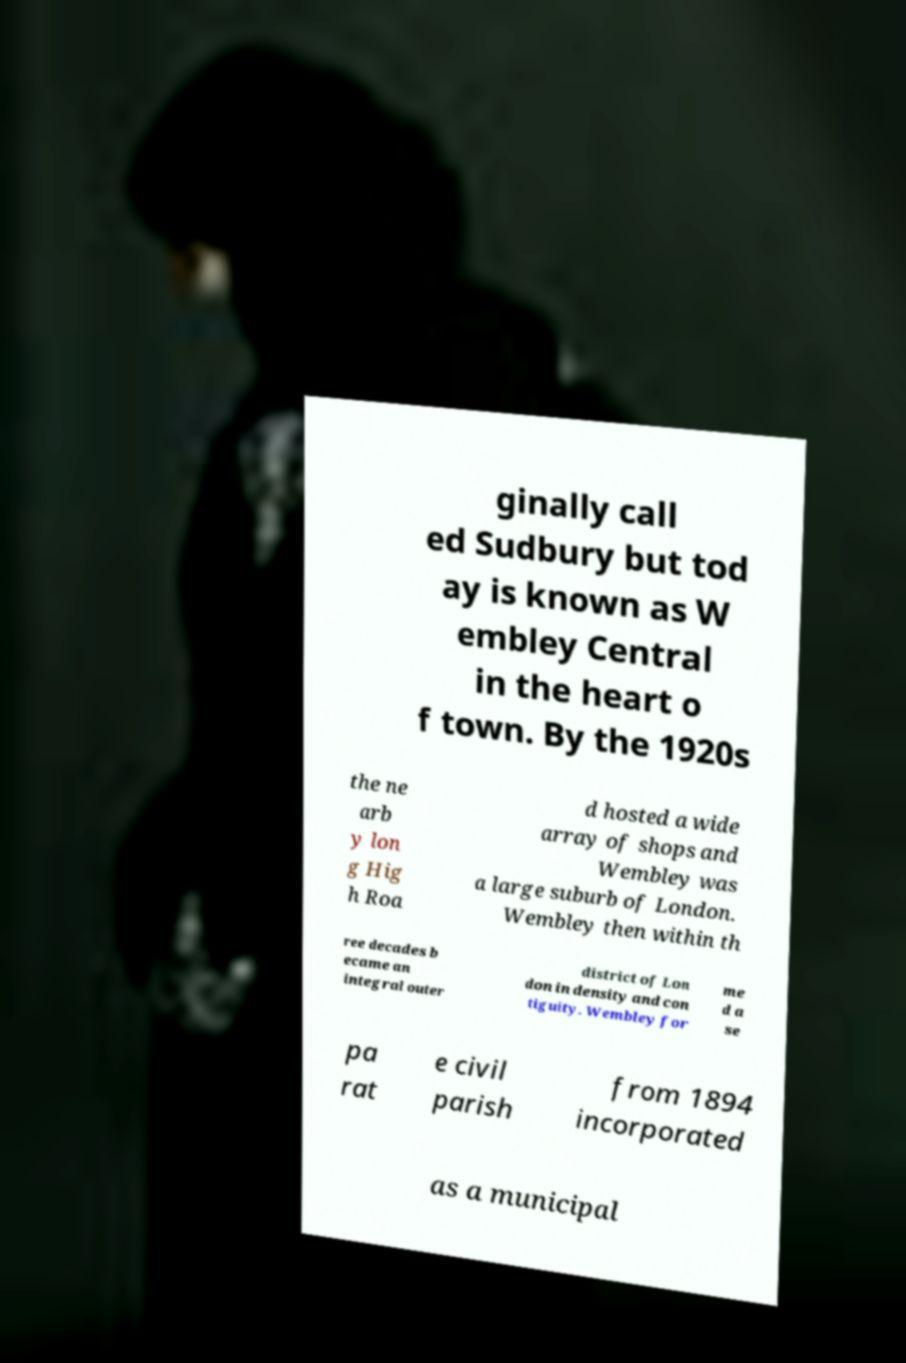Please read and relay the text visible in this image. What does it say? ginally call ed Sudbury but tod ay is known as W embley Central in the heart o f town. By the 1920s the ne arb y lon g Hig h Roa d hosted a wide array of shops and Wembley was a large suburb of London. Wembley then within th ree decades b ecame an integral outer district of Lon don in density and con tiguity. Wembley for me d a se pa rat e civil parish from 1894 incorporated as a municipal 